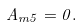Convert formula to latex. <formula><loc_0><loc_0><loc_500><loc_500>A _ { m 5 } = 0 .</formula> 